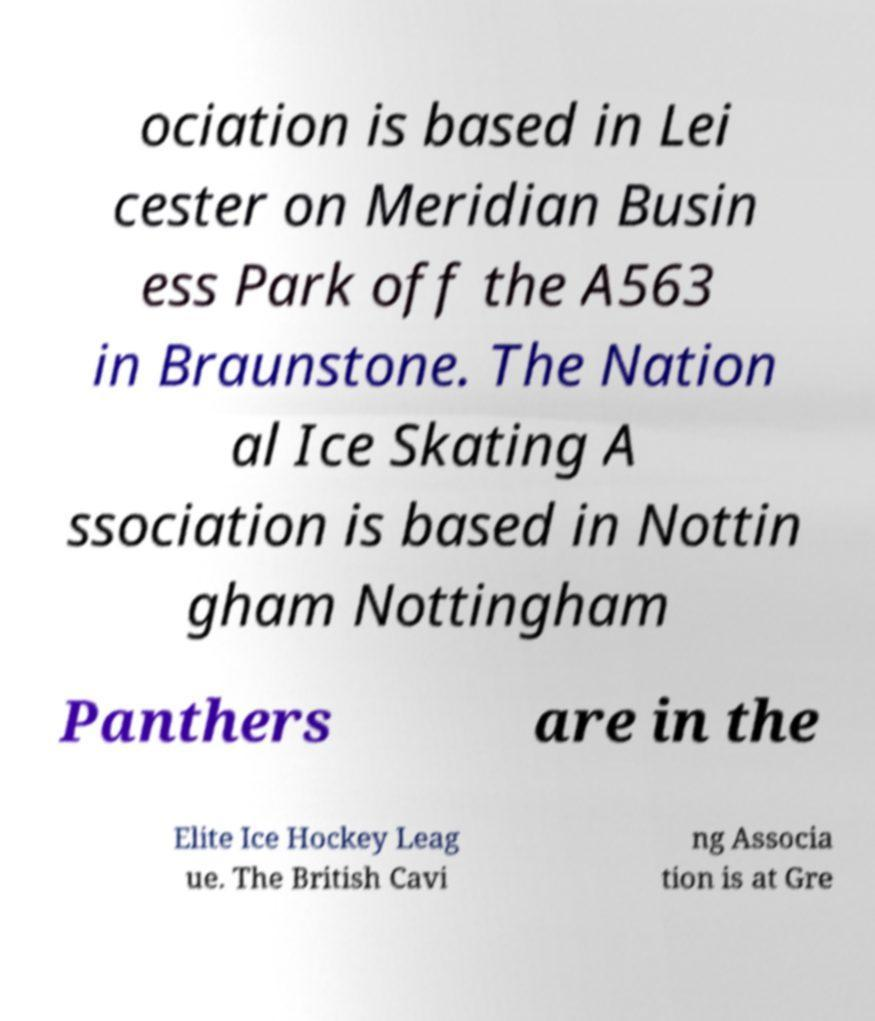Please identify and transcribe the text found in this image. ociation is based in Lei cester on Meridian Busin ess Park off the A563 in Braunstone. The Nation al Ice Skating A ssociation is based in Nottin gham Nottingham Panthers are in the Elite Ice Hockey Leag ue. The British Cavi ng Associa tion is at Gre 